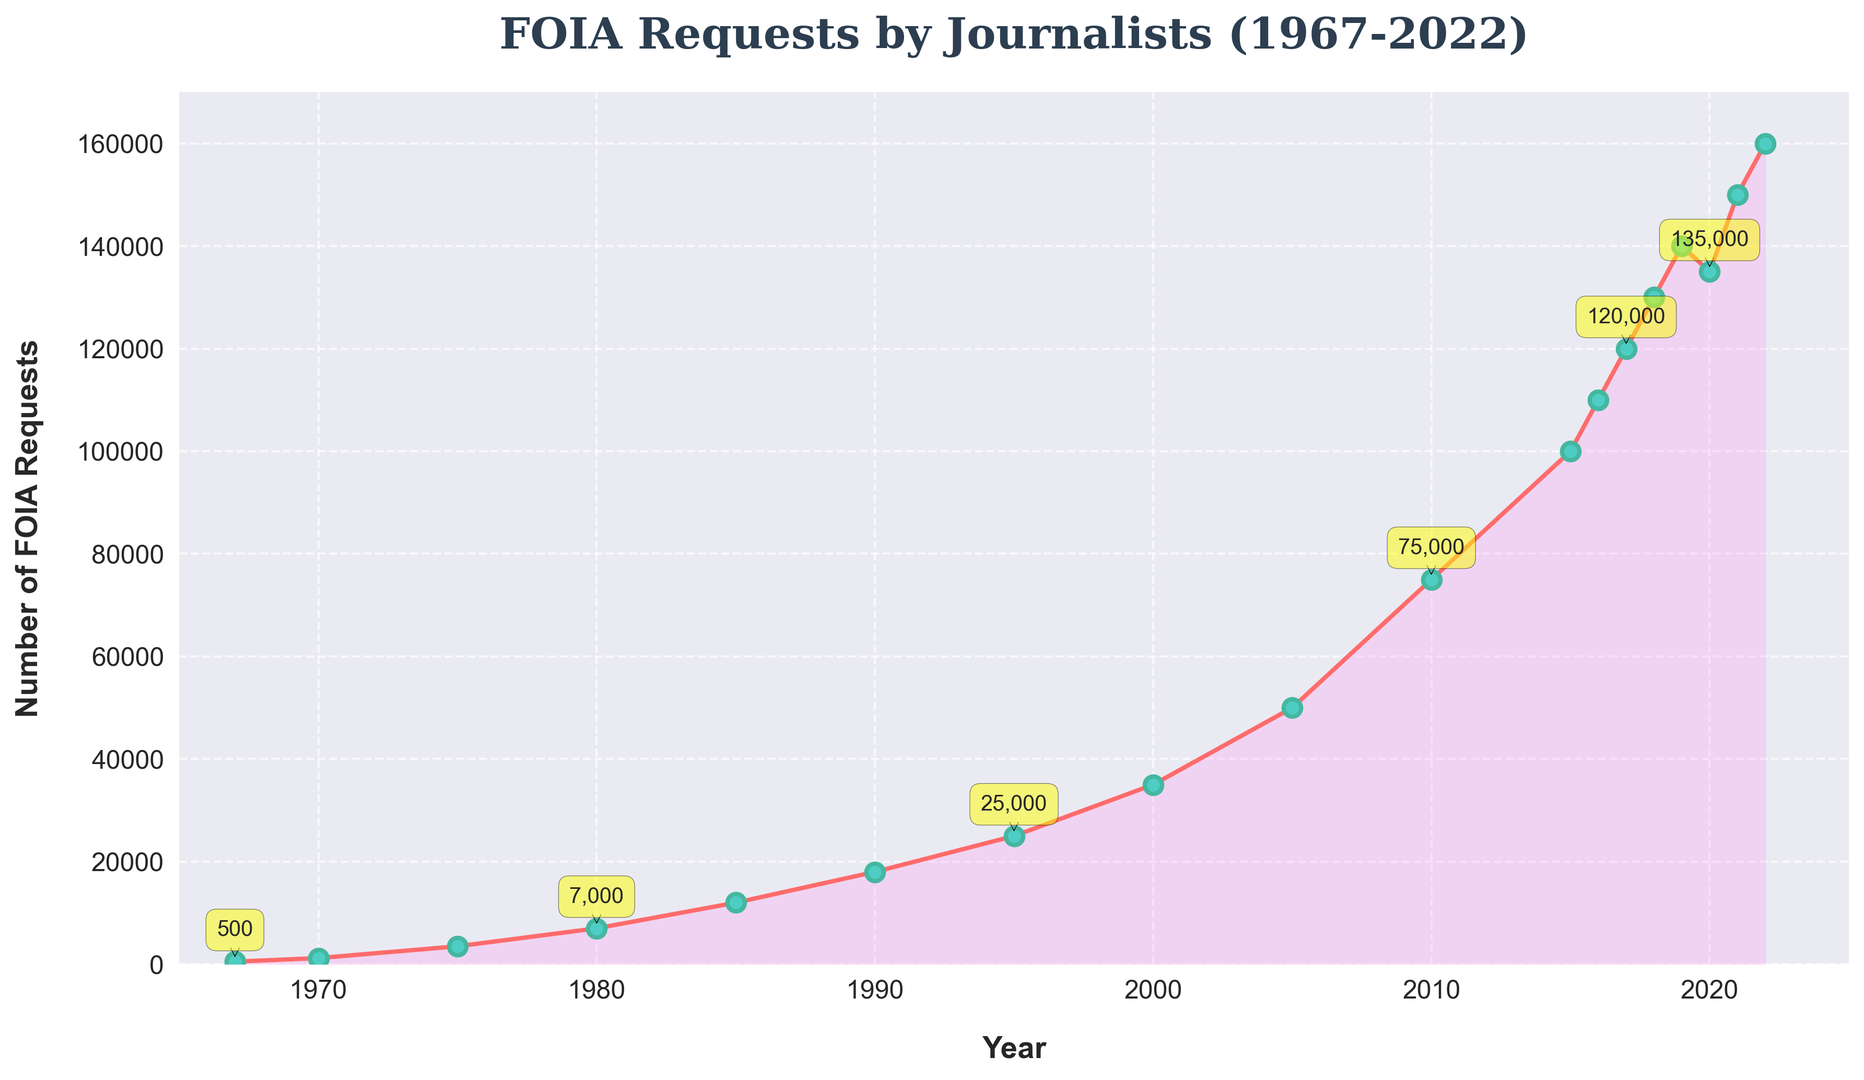How many FOIA requests were filed by journalists in 1985? Look directly at the data point for the year 1985 on the x-axis, then follow the corresponding y-axis value.
Answer: 12,000 In which year did the number of FOIA requests by journalists first exceed 50,000? Observe the plotted points and data labels, looking for the first instance where the number exceeds 50,000. This occurs between 2000 and 2005, specifically in 2005.
Answer: 2005 What is the total number of FOIA requests by journalists from 2015 to 2022? Summing the values for each year between 2015 and 2022: 100,000 (2015) + 110,000 (2016) + 120,000 (2017) + 130,000 (2018) + 140,000 (2019) + 135,000 (2020) + 150,000 (2021) + 160,000 (2022) = 945,000.
Answer: 945,000 In which decade did the FOIA requests by journalists see the largest increase? Calculate the increase for each decade by subtracting the initial year's value from the final year's value of the decade: 
    - 1967-1970: 1,200 - 500 = 700
    - 1970-1980: 7,000 - 1,200 = 5,800 
    - 1980-1990: 18,000 - 7,000 = 11,000 
    - 1990-2000: 35,000 - 18,000 = 17,000
    - 2000-2010: 75,000 - 35,000 = 40,000 
    - 2010-2020: 135,000 - 75,000 = 60,000 
The largest increase is from 2010 to 2020, with an increase of 60,000.
Answer: 2010-2020 How many more FOIA requests were filed in 2018 compared to 2010? Subtract the number of requests in 2010 from that in 2018: 130,000 - 75,000 = 55,000.
Answer: 55,000 What is the average number of FOIA requests filed per year from 1967 to 1975? Sum the values for the years 1967, 1970, and 1975, then divide by the number of years: (500 + 1,200 + 3,500) / 3 = 1,733.33.
Answer: 1,733 Which year saw a decrease in the number of FOIA requests compared to the previous year? Identify any downward slopes between consecutive data points in the graph. The number decreased between 2019 and 2020 (140,000 to 135,000).
Answer: 2020 What was the percentage increase in FOIA requests from 2000 to 2005? Calculate the percentage increase using the formula [(new value - old value) / old value] × 100: 
    [(50,000 - 35,000) / 35,000] × 100 = 42.86%.
Answer: 42.86% How did the number of FOIA requests change from 1967 to 2022? Identify the trend by comparing the first and last data points: 500 in 1967 to 160,000 in 2022 indicates a significant increase.
Answer: Increased In which year did FOIA requests reach 100,000 for the first time? Locate the point where the y-axis value first equals 100,000, which corresponds to the year 2015.
Answer: 2015 